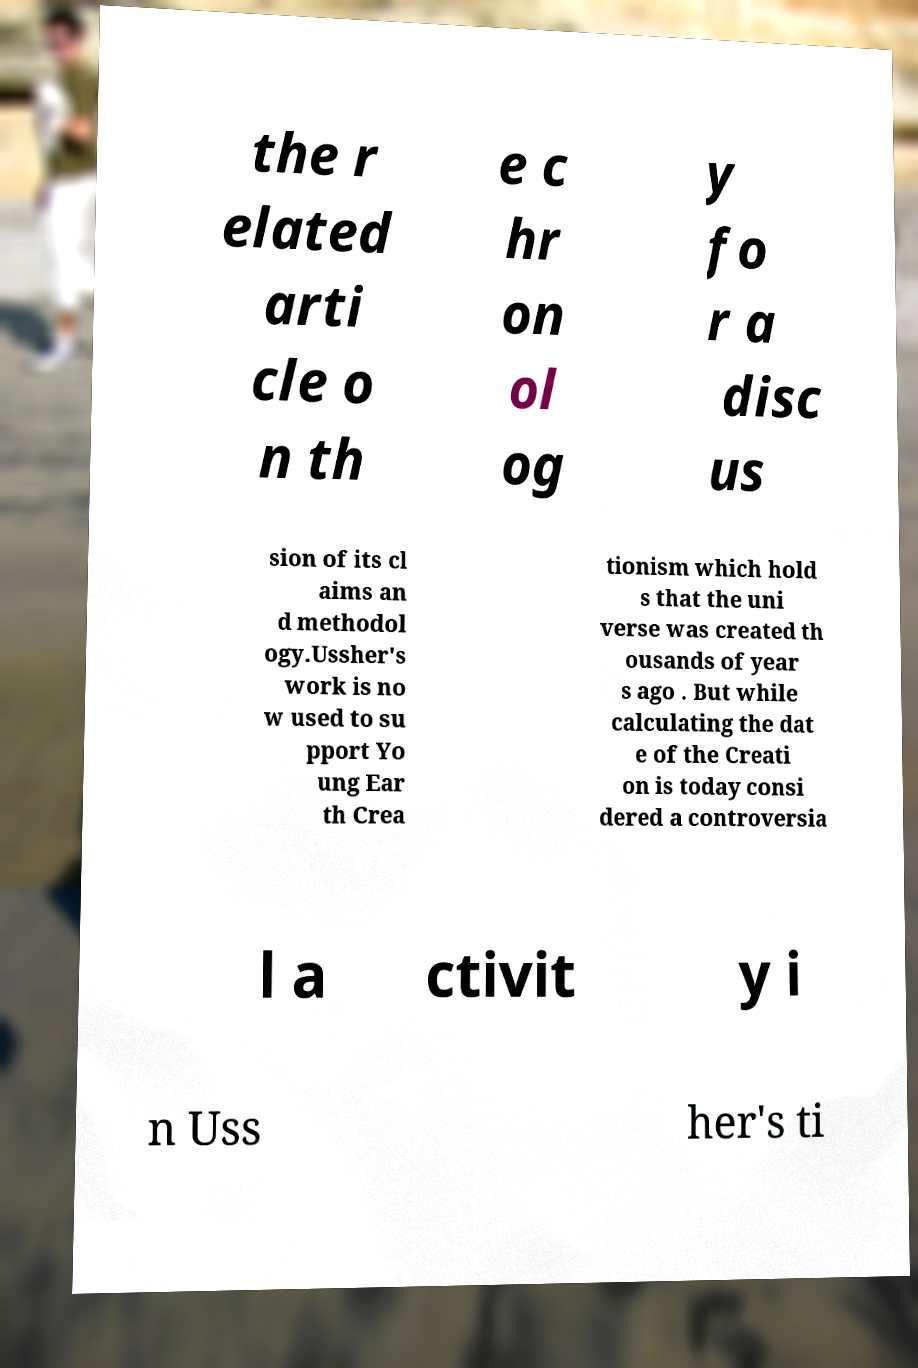Please read and relay the text visible in this image. What does it say? the r elated arti cle o n th e c hr on ol og y fo r a disc us sion of its cl aims an d methodol ogy.Ussher's work is no w used to su pport Yo ung Ear th Crea tionism which hold s that the uni verse was created th ousands of year s ago . But while calculating the dat e of the Creati on is today consi dered a controversia l a ctivit y i n Uss her's ti 